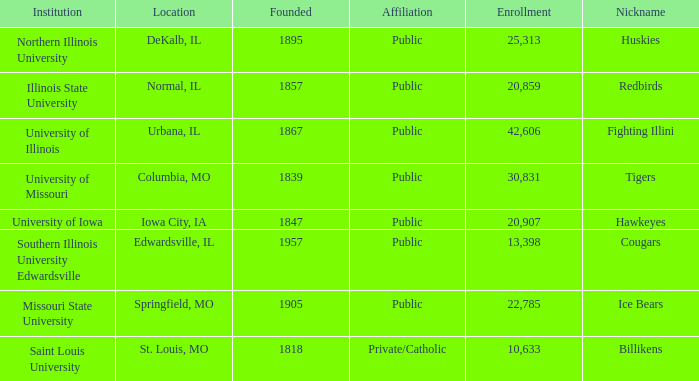Which institution is private/catholic? Saint Louis University. 